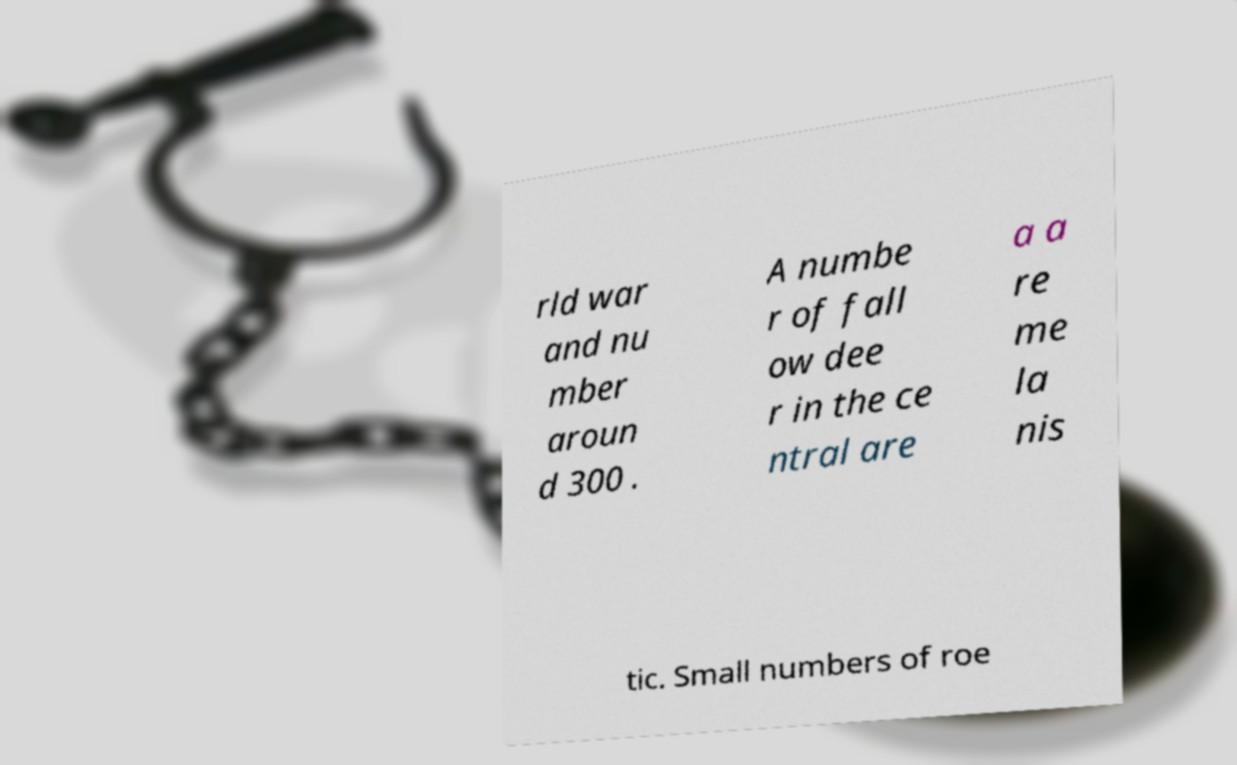There's text embedded in this image that I need extracted. Can you transcribe it verbatim? rld war and nu mber aroun d 300 . A numbe r of fall ow dee r in the ce ntral are a a re me la nis tic. Small numbers of roe 